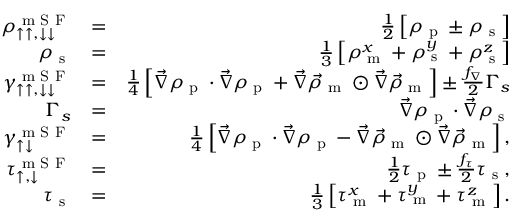<formula> <loc_0><loc_0><loc_500><loc_500>\begin{array} { r l r } { \rho _ { \uparrow \uparrow , \downarrow \downarrow } ^ { m S F } } & { = } & { \frac { 1 } { 2 } \left [ \rho _ { p } \pm \rho _ { s } \right ] } \\ { \rho _ { s } } & { = } & { \frac { 1 } { 3 } \left [ \rho _ { m } ^ { x } + \rho _ { s } ^ { y } + \rho _ { s } ^ { z } \right ] } \\ { \gamma _ { \uparrow \uparrow , \downarrow \downarrow } ^ { m S F } } & { = } & { \frac { 1 } { 4 } \left [ \vec { \nabla } \rho _ { p } \cdot \vec { \nabla } \rho _ { p } + \vec { \nabla } \vec { \rho } _ { m } \odot \vec { \nabla } \vec { \rho } _ { m } \right ] \pm \frac { f _ { \nabla } } { 2 } \Gamma _ { s } } \\ { \Gamma _ { s } } & { = } & { \vec { \nabla } \rho _ { p } \cdot \vec { \nabla } \rho _ { s } } \\ { \gamma _ { \uparrow \downarrow } ^ { m S F } } & { = } & { \frac { 1 } { 4 } \left [ \vec { \nabla } \rho _ { p } \cdot \vec { \nabla } \rho _ { p } - \vec { \nabla } \vec { \rho } _ { m } \odot \vec { \nabla } \vec { \rho } _ { m } \right ] , } \\ { \tau _ { \uparrow , \downarrow } ^ { m S F } } & { = } & { \frac { 1 } { 2 } \tau _ { p } \pm \frac { f _ { \tau } } { 2 } \tau _ { s } , } \\ { \tau _ { s } } & { = } & { \frac { 1 } { 3 } \left [ \tau _ { m } ^ { x } + \tau _ { m } ^ { y } + \tau _ { m } ^ { z } \right ] . } \end{array}</formula> 